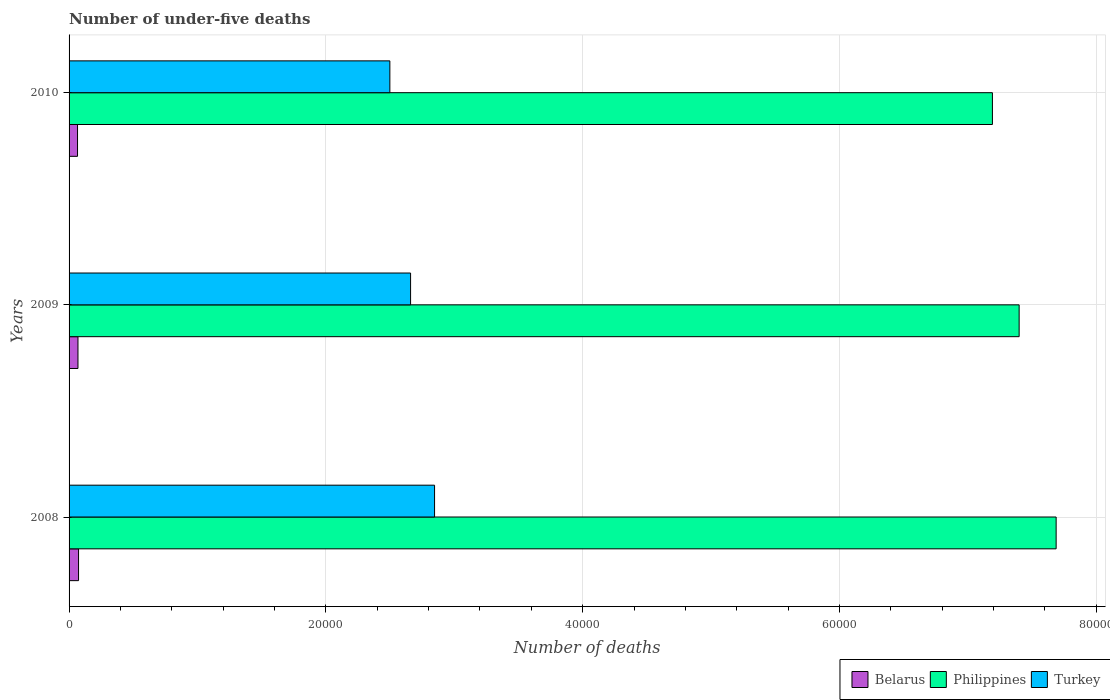How many different coloured bars are there?
Your answer should be very brief. 3. How many groups of bars are there?
Your answer should be very brief. 3. Are the number of bars on each tick of the Y-axis equal?
Your answer should be very brief. Yes. How many bars are there on the 2nd tick from the top?
Your response must be concise. 3. How many bars are there on the 3rd tick from the bottom?
Provide a short and direct response. 3. What is the label of the 1st group of bars from the top?
Provide a succinct answer. 2010. In how many cases, is the number of bars for a given year not equal to the number of legend labels?
Your response must be concise. 0. What is the number of under-five deaths in Belarus in 2008?
Keep it short and to the point. 738. Across all years, what is the maximum number of under-five deaths in Belarus?
Make the answer very short. 738. Across all years, what is the minimum number of under-five deaths in Turkey?
Keep it short and to the point. 2.50e+04. In which year was the number of under-five deaths in Philippines maximum?
Ensure brevity in your answer.  2008. In which year was the number of under-five deaths in Turkey minimum?
Provide a short and direct response. 2010. What is the total number of under-five deaths in Turkey in the graph?
Provide a succinct answer. 8.00e+04. What is the difference between the number of under-five deaths in Belarus in 2008 and that in 2010?
Keep it short and to the point. 79. What is the difference between the number of under-five deaths in Belarus in 2010 and the number of under-five deaths in Turkey in 2008?
Offer a very short reply. -2.78e+04. What is the average number of under-five deaths in Turkey per year?
Give a very brief answer. 2.67e+04. In the year 2010, what is the difference between the number of under-five deaths in Belarus and number of under-five deaths in Turkey?
Your response must be concise. -2.43e+04. In how many years, is the number of under-five deaths in Philippines greater than 36000 ?
Keep it short and to the point. 3. What is the ratio of the number of under-five deaths in Philippines in 2008 to that in 2010?
Offer a very short reply. 1.07. Is the number of under-five deaths in Turkey in 2009 less than that in 2010?
Make the answer very short. No. Is the difference between the number of under-five deaths in Belarus in 2008 and 2010 greater than the difference between the number of under-five deaths in Turkey in 2008 and 2010?
Give a very brief answer. No. What is the difference between the highest and the second highest number of under-five deaths in Philippines?
Give a very brief answer. 2881. What is the difference between the highest and the lowest number of under-five deaths in Belarus?
Your response must be concise. 79. In how many years, is the number of under-five deaths in Philippines greater than the average number of under-five deaths in Philippines taken over all years?
Your response must be concise. 1. Is the sum of the number of under-five deaths in Philippines in 2009 and 2010 greater than the maximum number of under-five deaths in Turkey across all years?
Provide a succinct answer. Yes. What does the 1st bar from the top in 2010 represents?
Give a very brief answer. Turkey. What does the 2nd bar from the bottom in 2009 represents?
Ensure brevity in your answer.  Philippines. Is it the case that in every year, the sum of the number of under-five deaths in Belarus and number of under-five deaths in Philippines is greater than the number of under-five deaths in Turkey?
Offer a very short reply. Yes. Does the graph contain grids?
Ensure brevity in your answer.  Yes. Where does the legend appear in the graph?
Keep it short and to the point. Bottom right. How many legend labels are there?
Your answer should be compact. 3. How are the legend labels stacked?
Provide a short and direct response. Horizontal. What is the title of the graph?
Your response must be concise. Number of under-five deaths. What is the label or title of the X-axis?
Keep it short and to the point. Number of deaths. What is the Number of deaths of Belarus in 2008?
Give a very brief answer. 738. What is the Number of deaths of Philippines in 2008?
Provide a short and direct response. 7.69e+04. What is the Number of deaths of Turkey in 2008?
Give a very brief answer. 2.85e+04. What is the Number of deaths in Belarus in 2009?
Ensure brevity in your answer.  693. What is the Number of deaths of Philippines in 2009?
Provide a succinct answer. 7.40e+04. What is the Number of deaths in Turkey in 2009?
Your answer should be compact. 2.66e+04. What is the Number of deaths in Belarus in 2010?
Provide a succinct answer. 659. What is the Number of deaths in Philippines in 2010?
Ensure brevity in your answer.  7.19e+04. What is the Number of deaths of Turkey in 2010?
Keep it short and to the point. 2.50e+04. Across all years, what is the maximum Number of deaths in Belarus?
Offer a terse response. 738. Across all years, what is the maximum Number of deaths in Philippines?
Offer a terse response. 7.69e+04. Across all years, what is the maximum Number of deaths in Turkey?
Your answer should be very brief. 2.85e+04. Across all years, what is the minimum Number of deaths in Belarus?
Offer a terse response. 659. Across all years, what is the minimum Number of deaths in Philippines?
Provide a succinct answer. 7.19e+04. Across all years, what is the minimum Number of deaths in Turkey?
Your answer should be compact. 2.50e+04. What is the total Number of deaths of Belarus in the graph?
Your response must be concise. 2090. What is the total Number of deaths in Philippines in the graph?
Provide a succinct answer. 2.23e+05. What is the total Number of deaths of Turkey in the graph?
Offer a very short reply. 8.00e+04. What is the difference between the Number of deaths of Belarus in 2008 and that in 2009?
Your answer should be compact. 45. What is the difference between the Number of deaths of Philippines in 2008 and that in 2009?
Your response must be concise. 2881. What is the difference between the Number of deaths in Turkey in 2008 and that in 2009?
Keep it short and to the point. 1868. What is the difference between the Number of deaths of Belarus in 2008 and that in 2010?
Offer a terse response. 79. What is the difference between the Number of deaths in Philippines in 2008 and that in 2010?
Keep it short and to the point. 4962. What is the difference between the Number of deaths of Turkey in 2008 and that in 2010?
Ensure brevity in your answer.  3481. What is the difference between the Number of deaths in Philippines in 2009 and that in 2010?
Give a very brief answer. 2081. What is the difference between the Number of deaths in Turkey in 2009 and that in 2010?
Offer a very short reply. 1613. What is the difference between the Number of deaths in Belarus in 2008 and the Number of deaths in Philippines in 2009?
Ensure brevity in your answer.  -7.33e+04. What is the difference between the Number of deaths of Belarus in 2008 and the Number of deaths of Turkey in 2009?
Offer a very short reply. -2.59e+04. What is the difference between the Number of deaths of Philippines in 2008 and the Number of deaths of Turkey in 2009?
Keep it short and to the point. 5.03e+04. What is the difference between the Number of deaths of Belarus in 2008 and the Number of deaths of Philippines in 2010?
Ensure brevity in your answer.  -7.12e+04. What is the difference between the Number of deaths in Belarus in 2008 and the Number of deaths in Turkey in 2010?
Provide a short and direct response. -2.42e+04. What is the difference between the Number of deaths of Philippines in 2008 and the Number of deaths of Turkey in 2010?
Provide a short and direct response. 5.19e+04. What is the difference between the Number of deaths in Belarus in 2009 and the Number of deaths in Philippines in 2010?
Provide a short and direct response. -7.12e+04. What is the difference between the Number of deaths of Belarus in 2009 and the Number of deaths of Turkey in 2010?
Give a very brief answer. -2.43e+04. What is the difference between the Number of deaths in Philippines in 2009 and the Number of deaths in Turkey in 2010?
Offer a terse response. 4.90e+04. What is the average Number of deaths of Belarus per year?
Keep it short and to the point. 696.67. What is the average Number of deaths of Philippines per year?
Offer a very short reply. 7.43e+04. What is the average Number of deaths in Turkey per year?
Offer a very short reply. 2.67e+04. In the year 2008, what is the difference between the Number of deaths of Belarus and Number of deaths of Philippines?
Provide a succinct answer. -7.61e+04. In the year 2008, what is the difference between the Number of deaths of Belarus and Number of deaths of Turkey?
Provide a short and direct response. -2.77e+04. In the year 2008, what is the difference between the Number of deaths in Philippines and Number of deaths in Turkey?
Ensure brevity in your answer.  4.84e+04. In the year 2009, what is the difference between the Number of deaths in Belarus and Number of deaths in Philippines?
Your answer should be very brief. -7.33e+04. In the year 2009, what is the difference between the Number of deaths of Belarus and Number of deaths of Turkey?
Provide a succinct answer. -2.59e+04. In the year 2009, what is the difference between the Number of deaths of Philippines and Number of deaths of Turkey?
Offer a terse response. 4.74e+04. In the year 2010, what is the difference between the Number of deaths in Belarus and Number of deaths in Philippines?
Offer a terse response. -7.13e+04. In the year 2010, what is the difference between the Number of deaths in Belarus and Number of deaths in Turkey?
Give a very brief answer. -2.43e+04. In the year 2010, what is the difference between the Number of deaths in Philippines and Number of deaths in Turkey?
Make the answer very short. 4.69e+04. What is the ratio of the Number of deaths of Belarus in 2008 to that in 2009?
Your response must be concise. 1.06. What is the ratio of the Number of deaths of Philippines in 2008 to that in 2009?
Your response must be concise. 1.04. What is the ratio of the Number of deaths in Turkey in 2008 to that in 2009?
Offer a terse response. 1.07. What is the ratio of the Number of deaths of Belarus in 2008 to that in 2010?
Ensure brevity in your answer.  1.12. What is the ratio of the Number of deaths in Philippines in 2008 to that in 2010?
Make the answer very short. 1.07. What is the ratio of the Number of deaths of Turkey in 2008 to that in 2010?
Your answer should be compact. 1.14. What is the ratio of the Number of deaths in Belarus in 2009 to that in 2010?
Your answer should be very brief. 1.05. What is the ratio of the Number of deaths of Philippines in 2009 to that in 2010?
Your answer should be very brief. 1.03. What is the ratio of the Number of deaths in Turkey in 2009 to that in 2010?
Your answer should be very brief. 1.06. What is the difference between the highest and the second highest Number of deaths in Belarus?
Your answer should be compact. 45. What is the difference between the highest and the second highest Number of deaths in Philippines?
Your answer should be very brief. 2881. What is the difference between the highest and the second highest Number of deaths of Turkey?
Your response must be concise. 1868. What is the difference between the highest and the lowest Number of deaths in Belarus?
Offer a very short reply. 79. What is the difference between the highest and the lowest Number of deaths in Philippines?
Your response must be concise. 4962. What is the difference between the highest and the lowest Number of deaths in Turkey?
Give a very brief answer. 3481. 